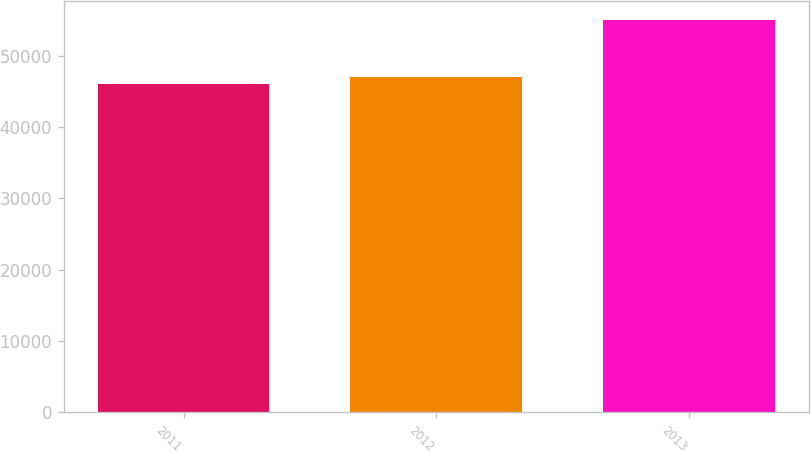<chart> <loc_0><loc_0><loc_500><loc_500><bar_chart><fcel>2011<fcel>2012<fcel>2013<nl><fcel>46114<fcel>47091<fcel>54980<nl></chart> 